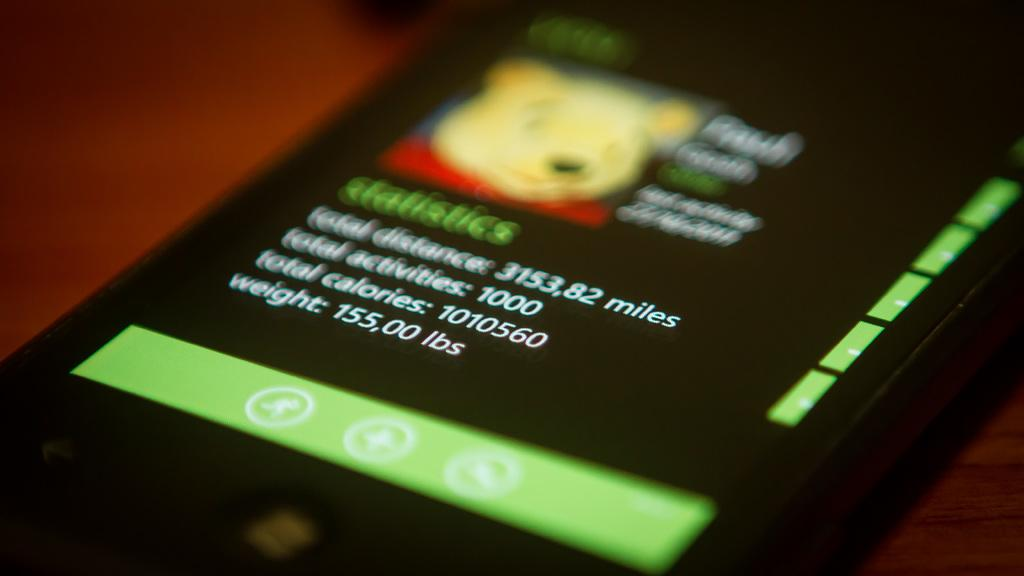<image>
Render a clear and concise summary of the photo. A phone screen shows activity statistics from an app. 